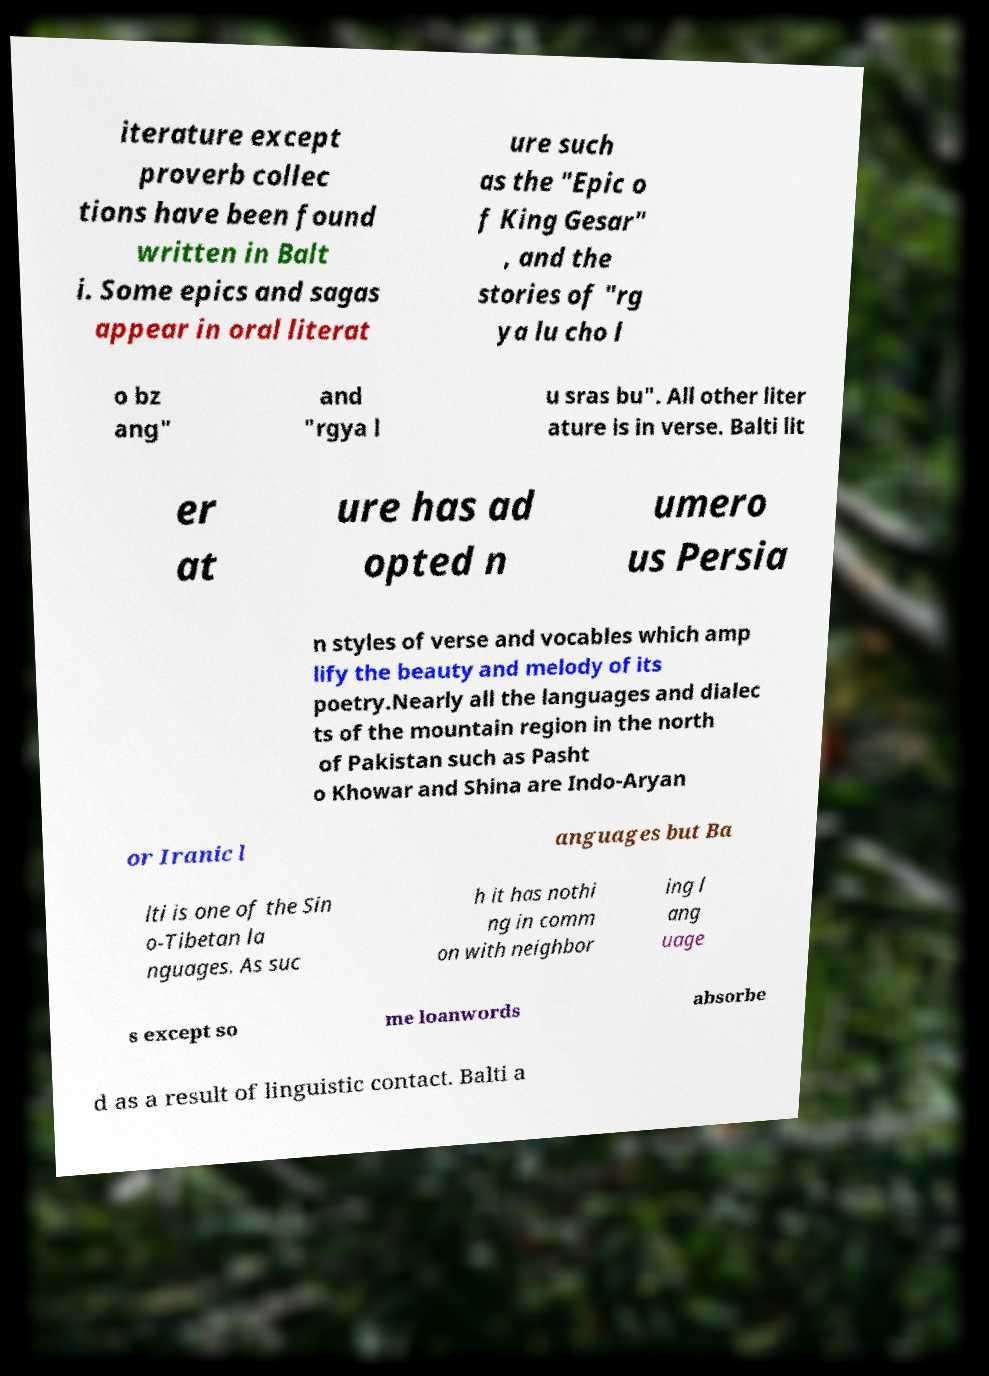Could you assist in decoding the text presented in this image and type it out clearly? iterature except proverb collec tions have been found written in Balt i. Some epics and sagas appear in oral literat ure such as the "Epic o f King Gesar" , and the stories of "rg ya lu cho l o bz ang" and "rgya l u sras bu". All other liter ature is in verse. Balti lit er at ure has ad opted n umero us Persia n styles of verse and vocables which amp lify the beauty and melody of its poetry.Nearly all the languages and dialec ts of the mountain region in the north of Pakistan such as Pasht o Khowar and Shina are Indo-Aryan or Iranic l anguages but Ba lti is one of the Sin o-Tibetan la nguages. As suc h it has nothi ng in comm on with neighbor ing l ang uage s except so me loanwords absorbe d as a result of linguistic contact. Balti a 